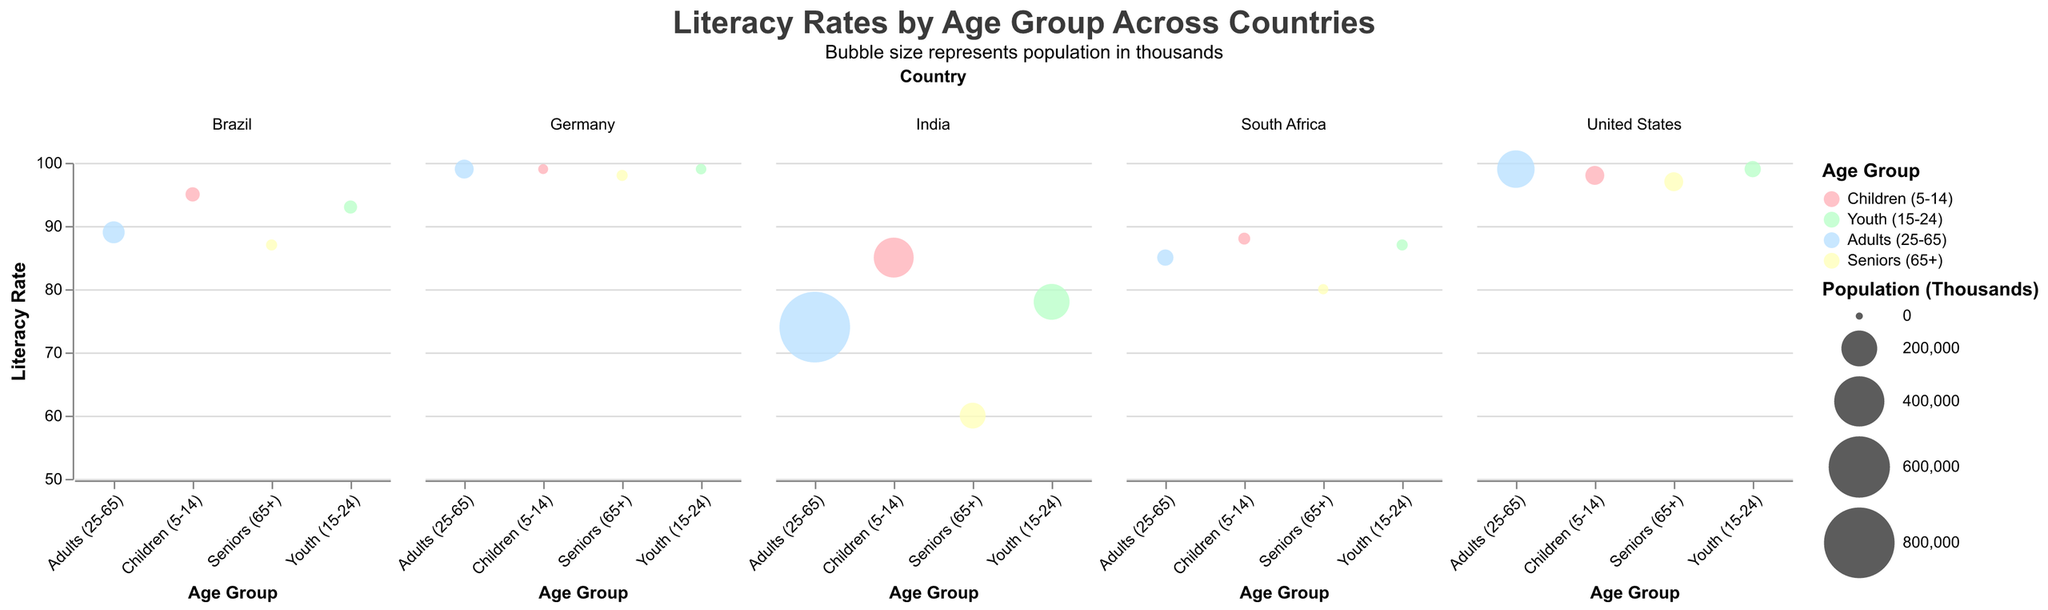How many age groups are represented in the subplot? There are four age groups: Children (5-14), Youth (15-24), Adults (25-65), and Seniors (65+). These age groups are categorized on the x-axis in the subplot.
Answer: Four Which country has the highest literacy rate for Youth (15-24)? To find the highest literacy rate for Youth (15-24), compare the literacy rates for that age group across all countries. Germany and the United States both have a literacy rate of 99.0 for Youth (15-24).
Answer: Germany and United States What is the literacy rate for Seniors (65+) in India? Locate the data point for Seniors (65+) in India on the figure. The literacy rate for this group is 60.0.
Answer: 60.0 What age group in Brazil has the smallest population? By examining the bubble sizes for each age group in Brazil, the smallest bubble represents the Seniors (65+), indicating they have the smallest population.
Answer: Seniors (65+) Compare the literacy rates of Children (5-14) in the United States and India. Which country has a higher literacy rate in this age group? Look at the literacy rates for Children (5-14) in both the United States and India. The United States has a literacy rate of 98.0, while India has a literacy rate of 85.0, making the United States higher.
Answer: United States Which country has the highest overall literacy rate for Adults (25-65)? To determine the highest overall literacy rate for Adults (25-65), compare the literacy rates across all countries for this age group. Both Germany and the United States have a literacy rate of 99.0 for Adults (25-65).
Answer: Germany and United States Calculate the average literacy rate for Youth (15-24) across all countries. Summing up the literacy rates for Youth (15-24) in all countries (99 + 78 + 93 + 99 + 87) and dividing by the number of countries (5) gives (456 / 5 = 91.2).
Answer: 91.2 In which country do Seniors (65+) have the highest literacy rate? By comparing the literacy rates for Seniors (65+) across all countries, Germany has the highest literacy rate at 98.0.
Answer: Germany Is the literacy rate for Youth (15-24) in Brazil higher or lower than in South Africa? Comparing the literacy rates for Youth (15-24), Brazil has a literacy rate of 93.0, while South Africa has a rate of 87.0, thus Brazil is higher.
Answer: Higher Which age group in India has the lowest literacy rate and what is it? Observing the literacy rates for each age group in India, Seniors (65+) have the lowest literacy rate at 60.0.
Answer: Seniors (65+), 60.0 